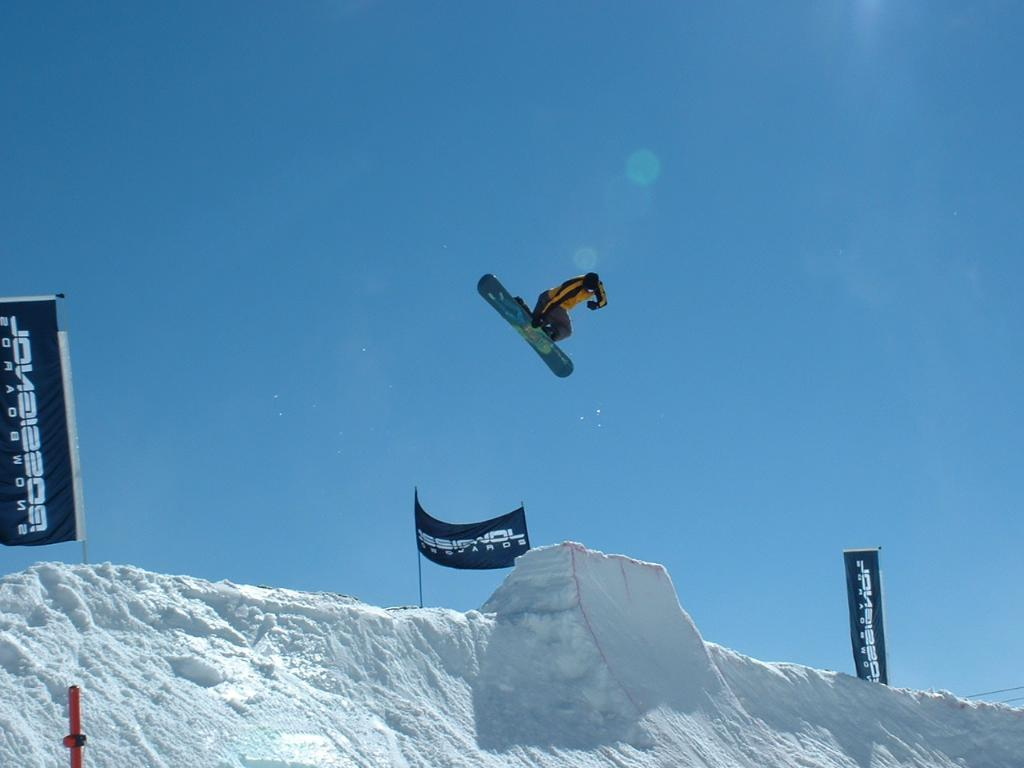What activity is the person in the image engaged in? The person in the image is doing snowboarding. What type of terrain is visible in the image? There is snow visible in the image. What can be seen on the snow in the image? There are banners with text on the snow. What is visible in the background of the image? The sky is visible in the background of the image. Can you see a robin perched on a branch in the image? There is no robin or branch present in the image; it features a person snowboarding in the snow. 